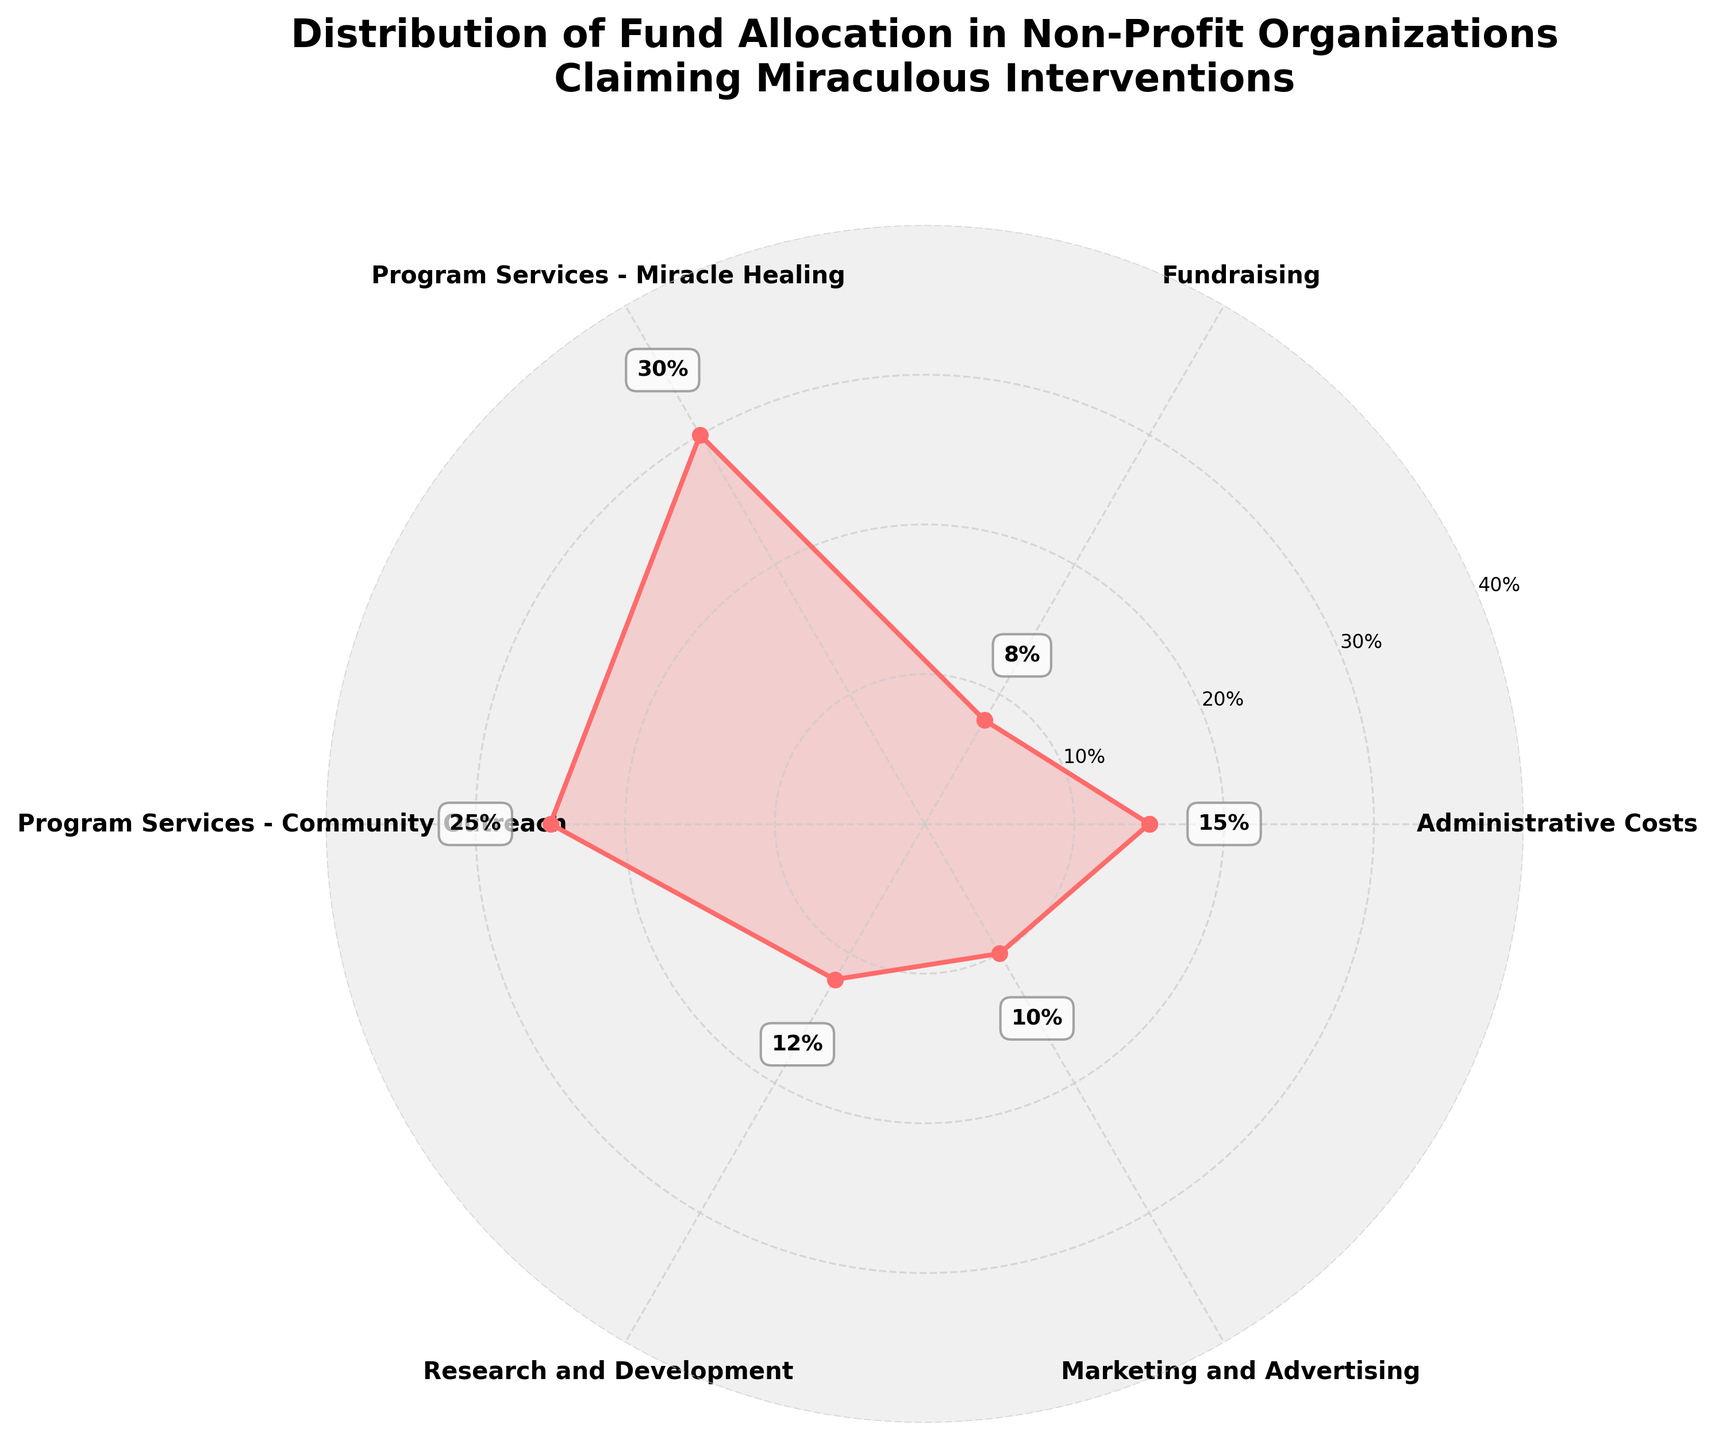What is the title of the plot? The title is displayed prominently at the top of the figure and is often used to quickly understand the main topic of the chart. For this figure, it's centered and written in bold font above the plot area.
Answer: Distribution of Fund Allocation in Non-Profit Organizations Claiming Miraculous Interventions What is the largest category in terms of fund allocation? To determine the largest category, look at the category with the highest percentage value marked on the chart. This category will have the farthest data point from the center of the polar chart.
Answer: Program Services - Miracle Healing How much is spent on Program Services - Community Outreach relative to Fundraising? To find this, compare the percentages for Program Services - Community Outreach and Fundraising from the chart. The value for Community Outreach is higher, so you need to subtract the percentage of Fundraising from it.
Answer: 17% Which category has the smallest fraction of funds? The category with the smallest fraction of funds will have the nearest point to the center of the polar chart. Look for the category with the lowest percentage value.
Answer: Fundraising What is the combined fund allocation for Administrative Costs and Marketing and Advertising? Add the percentages of Administrative Costs and Marketing and Advertising together. From the chart, Administrative Costs are 15% and Marketing and Advertising are 10%.
Answer: 25% Is the percentage of funds allocated to Research and Development greater than Marketing and Advertising? Compare the values of Research and Development (12%) with Marketing and Advertising (10%) shown on the chart. Since 12% is greater than 10%, the answer is yes.
Answer: Yes How does the allocation to Program Services - Miracle Healing compare to the total allocation for both Administrative Costs and Fundraising? First, add the percentages of Administrative Costs and Fundraising. Then, compare the sum to the percentage allocated to Program Services - Miracle Healing. Administrative Costs (15%) and Fundraising (8%) sum to 23%, which is less than the 30% for Program Services - Miracle Healing.
Answer: Greater What percentage of the total funds is allocated to Program Services (both categories combined)? Add the percentages of both Program Services - Miracle Healing and Program Services - Community Outreach. From the chart, these categories are 30% and 25%, respectively.
Answer: 55% Which category contributes to approximately one-fourth of the total allocation? Identify the category with a percentage close to 25% by checking the values on the chart. Program Services - Community Outreach matches this criterion at exactly 25%.
Answer: Program Services - Community Outreach 